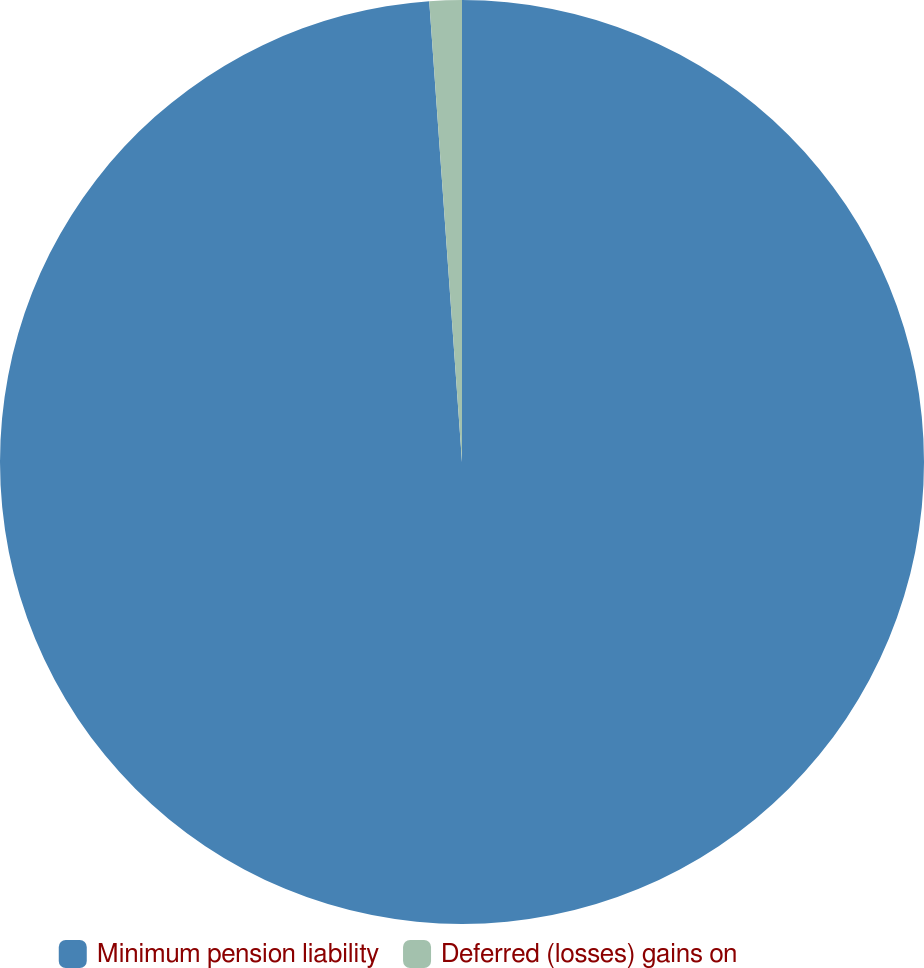<chart> <loc_0><loc_0><loc_500><loc_500><pie_chart><fcel>Minimum pension liability<fcel>Deferred (losses) gains on<nl><fcel>98.87%<fcel>1.13%<nl></chart> 